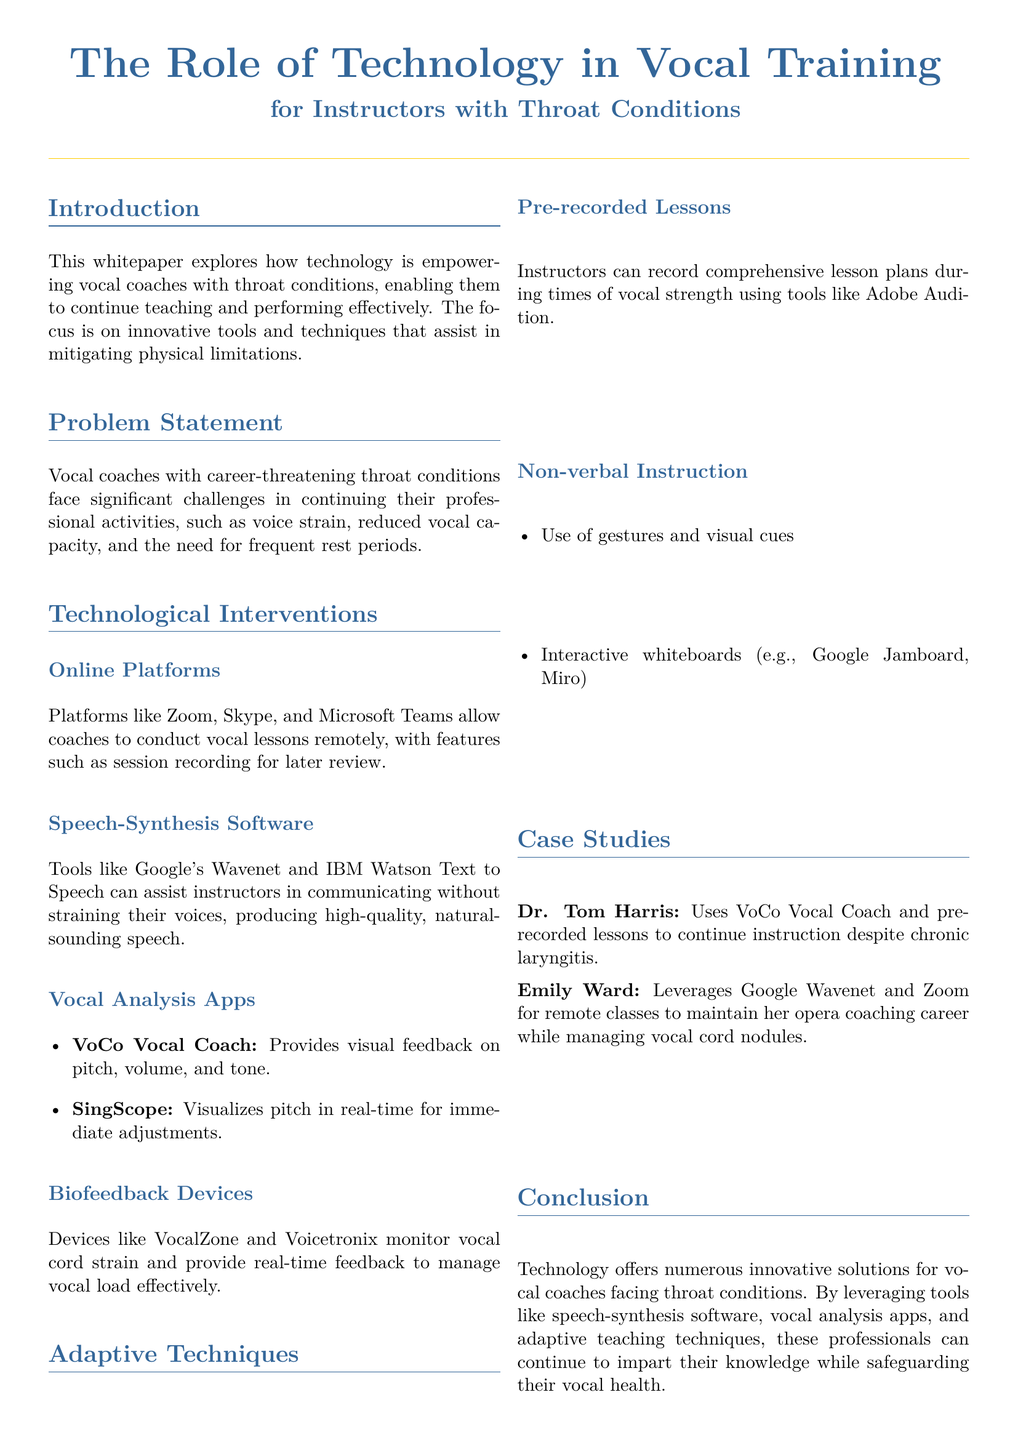What is the main focus of the whitepaper? The main focus is on innovative tools and techniques that assist in mitigating physical limitations for vocal coaches with throat conditions.
Answer: Innovative tools and techniques What technology allows vocal coaches to conduct lessons remotely? Platforms like Zoom, Skype, and Microsoft Teams are mentioned for conducting remote lessons, allowing for session recording as well.
Answer: Zoom, Skype, Microsoft Teams Which device monitors vocal cord strain? The document explains that devices like VocalZone and Voicetronix are used to monitor vocal cord strain and provide feedback.
Answer: VocalZone, Voicetronix Who is a case study example that uses VoCo Vocal Coach? The document mentions Dr. Tom Harris as an example who uses VoCo Vocal Coach for instruction despite chronic laryngitis.
Answer: Dr. Tom Harris What method helps instructors teach without vocal strain? The use of pre-recorded lessons during times of vocal strength is one method described that helps instructors avoid vocal strain.
Answer: Pre-recorded lessons Which speech-synthesis software is used by Emily Ward? Emily Ward leverages Google Wavenet for her remote classes while managing vocal cord nodules.
Answer: Google Wavenet What is the role of non-verbal instruction? Non-verbal instruction includes the use of gestures and interactive whiteboards, which allows teaching without speaking.
Answer: Gestures and visual cues What color is the title in the document? The main title uses the color defined as maincolor in the document, which is an RGB color set to (51, 102, 153).
Answer: RGB(51, 102, 153) 